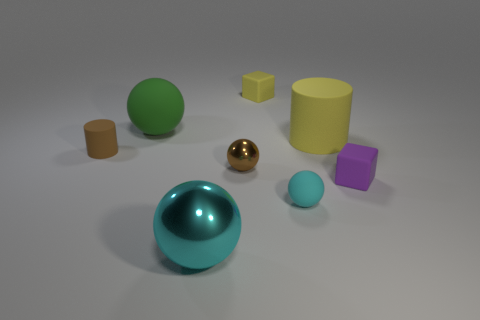Add 1 large blue shiny things. How many objects exist? 9 Subtract all cylinders. How many objects are left? 6 Add 3 cylinders. How many cylinders are left? 5 Add 6 big shiny objects. How many big shiny objects exist? 7 Subtract 1 yellow cylinders. How many objects are left? 7 Subtract all shiny balls. Subtract all cyan matte objects. How many objects are left? 5 